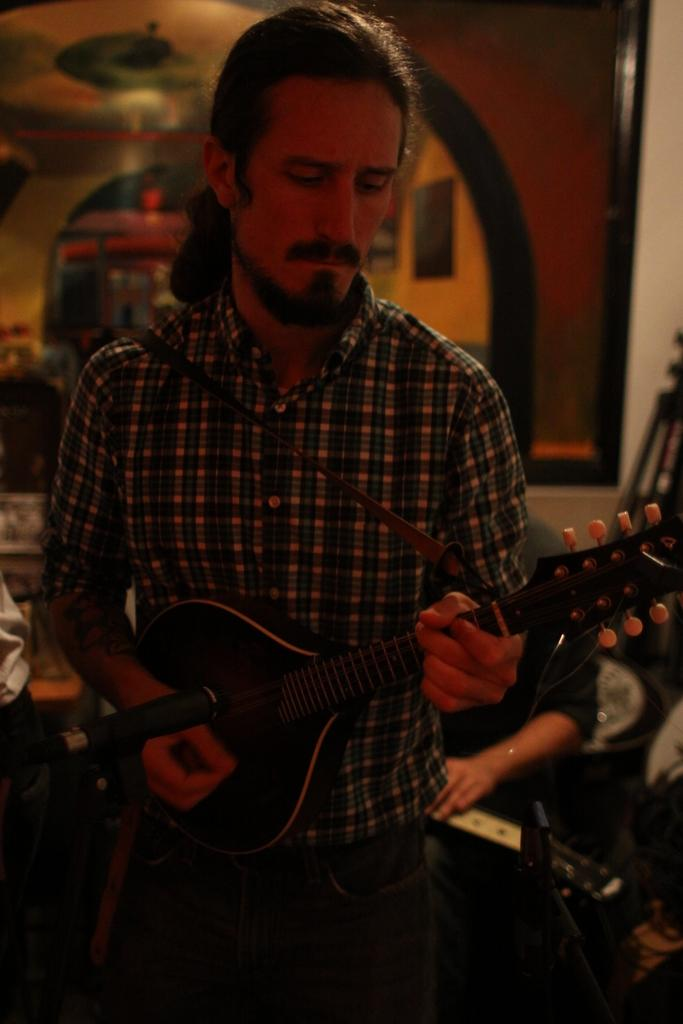What is the man in the image doing? The man is playing the guitar. What is the man holding in the image? The man is holding a guitar. Can you describe the other person in the image? There is another person sitting in the image. What can be seen in the background of the image? There is a wall and a stand in the background of the image. What is the yak doing in the image? There is no yak present in the image. Are the friends having an argument in the image? The provided facts do not mention any friends or arguments in the image. 